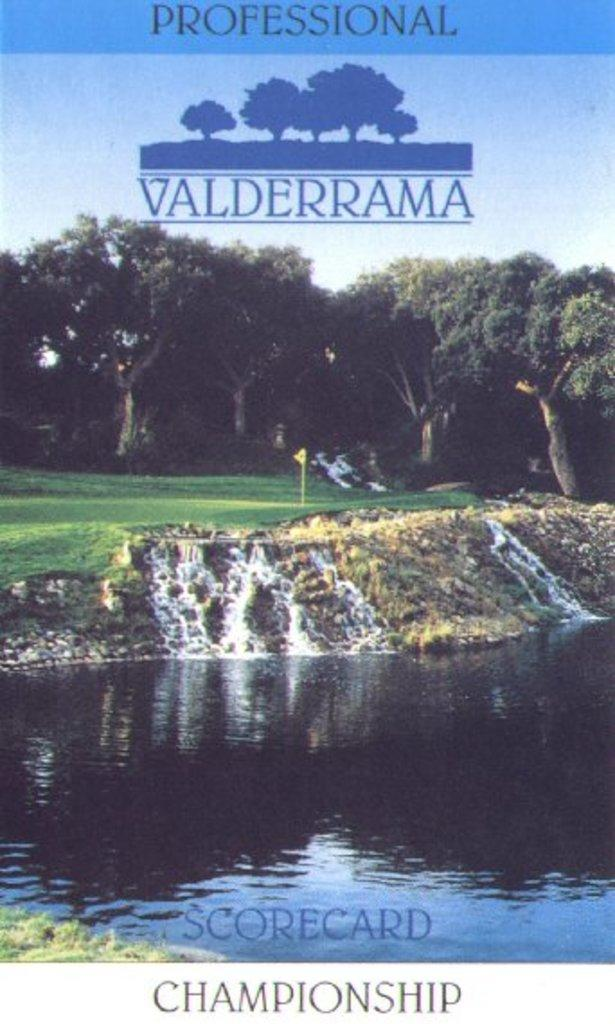Provide a one-sentence caption for the provided image. A scorecard, from the Valderrama course, has a photo of a hole with a water trap. 